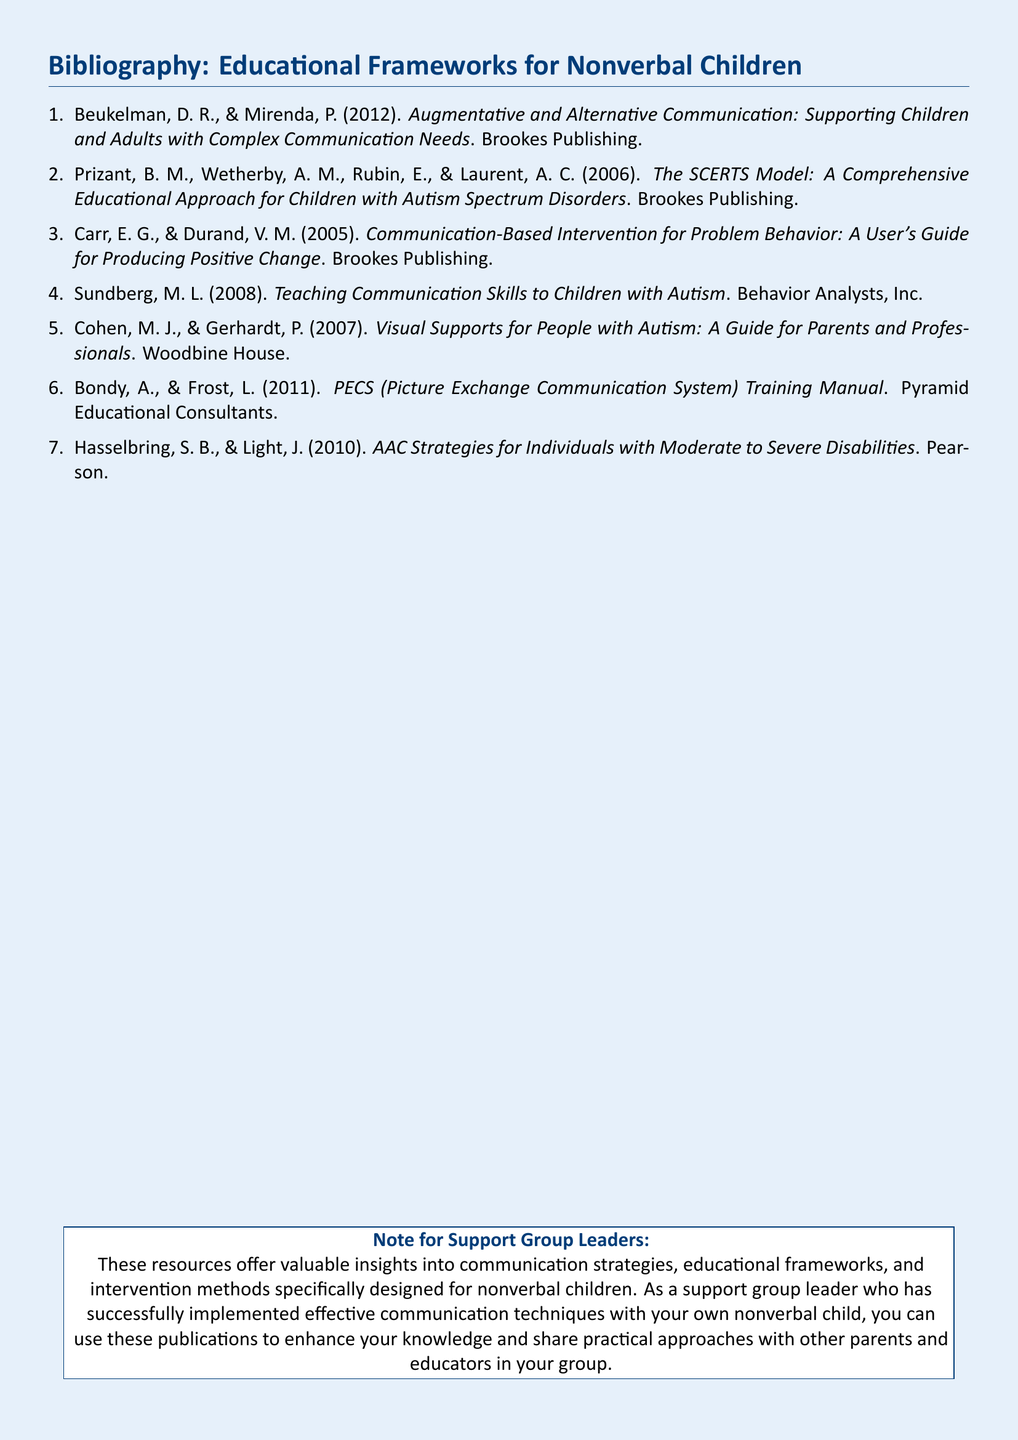What is the title of the first book listed? The title of the first book is the first item in the bibliography section.
Answer: Augmentative and Alternative Communication: Supporting Children and Adults with Complex Communication Needs Who are the authors of the SCERTS model? The authors of the SCERTS model are listed in the second item of the bibliography.
Answer: Prizant, Wetherby, Rubin, Laurent In what year was the Communication-Based Intervention for Problem Behavior published? The publication year is included in the citation for the respective book in the bibliography.
Answer: 2005 How many books are cited in the bibliography? The number of books can be counted from the list of items in the document.
Answer: 7 What is the main focus of the book by Cohen and Gerhardt? The focus can be derived from the title of the book in the bibliography.
Answer: Visual Supports for People with Autism What type of publication is this document? The document type is indicated by its content and format as a reference list.
Answer: Bibliography Who published the PECS Training Manual? The publisher can be found in the citation of the specific book in the bibliography.
Answer: Pyramid Educational Consultants What is a key strategy emphasized in the resources? A definite strategy is highlighted in the note at the bottom of the document.
Answer: Communication strategies 